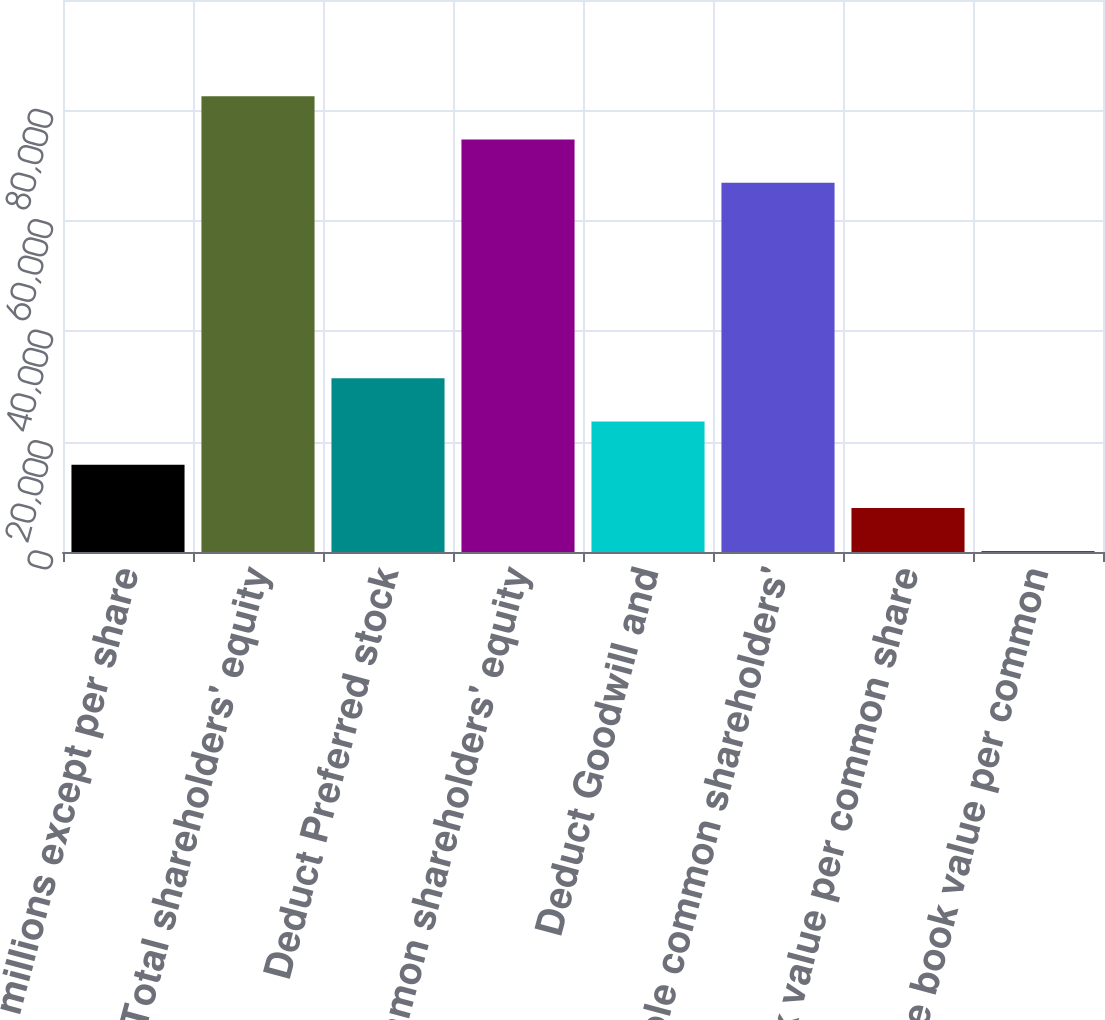<chart> <loc_0><loc_0><loc_500><loc_500><bar_chart><fcel>in millions except per share<fcel>Total shareholders' equity<fcel>Deduct Preferred stock<fcel>Common shareholders' equity<fcel>Deduct Goodwill and<fcel>Tangible common shareholders'<fcel>Book value per common share<fcel>Tangible book value per common<nl><fcel>15807.9<fcel>82555.8<fcel>31472.7<fcel>74723.4<fcel>23640.3<fcel>66891<fcel>7975.5<fcel>143.11<nl></chart> 